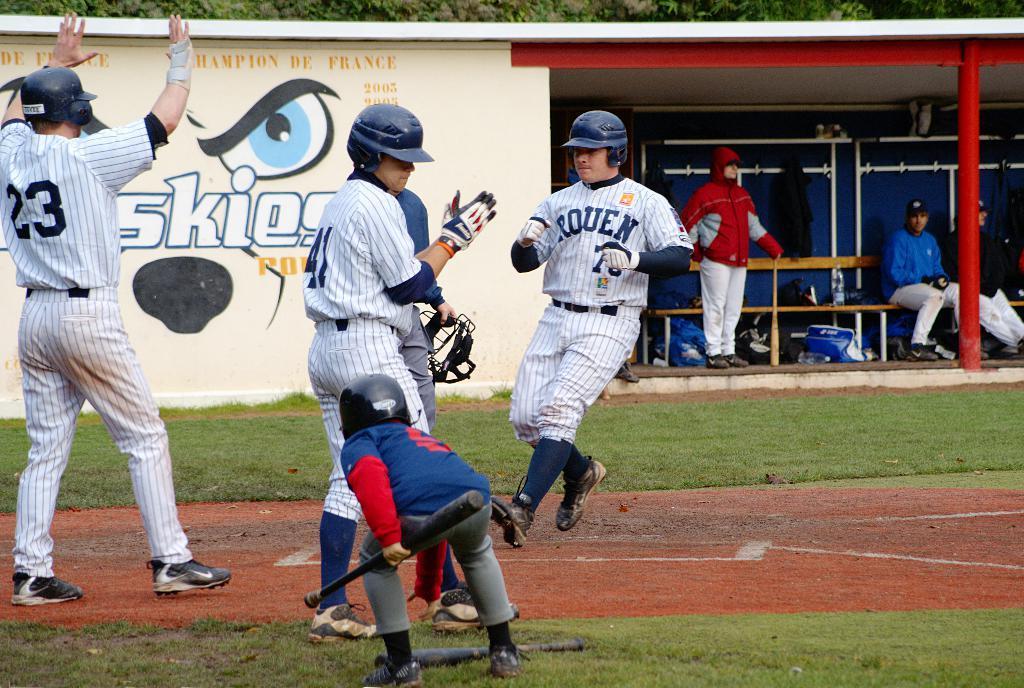Describe this image in one or two sentences. In this image, we can see few people. Few are playing a game on the ground. At the bottom, kid is holding a stick. Background we can see shed, few people are sitting on the bench. Here we can see some objects, rods, pole, painting on the wall. 